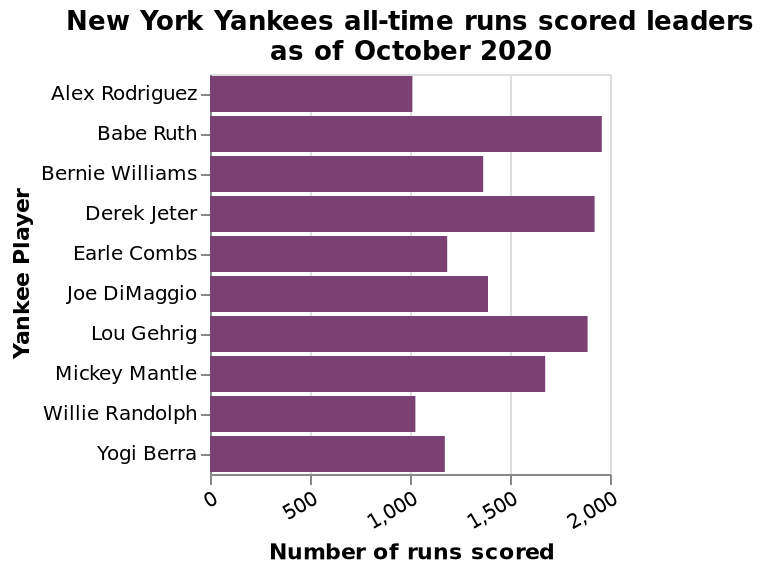<image>
What is the approximate range of runs scored for Babe Ruth Williams? The approximate range of runs scored for Babe Ruth Williams is close to 2,000. please summary the statistics and relations of the chart Babe Ruth Williams has the largest number of runs scored with close to 2,000, closely followed by Derek jeter. Six of the ten Yankee players average between 1,000 to approx 1,4000 runs. 